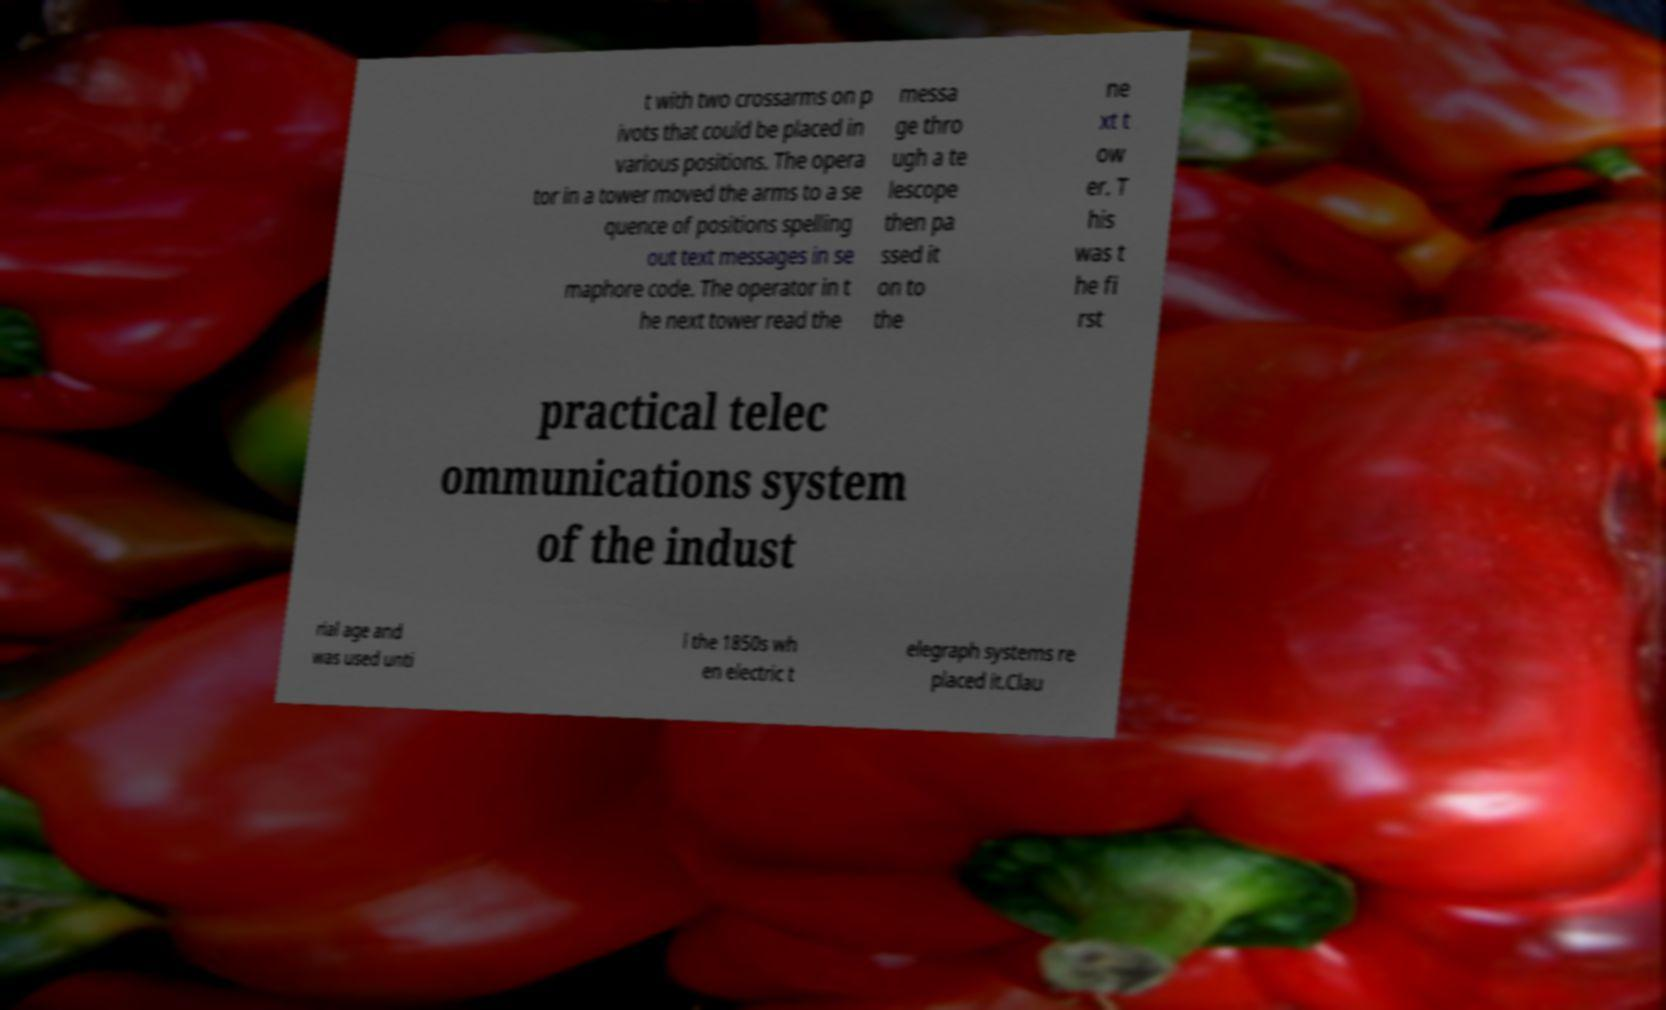What messages or text are displayed in this image? I need them in a readable, typed format. t with two crossarms on p ivots that could be placed in various positions. The opera tor in a tower moved the arms to a se quence of positions spelling out text messages in se maphore code. The operator in t he next tower read the messa ge thro ugh a te lescope then pa ssed it on to the ne xt t ow er. T his was t he fi rst practical telec ommunications system of the indust rial age and was used unti l the 1850s wh en electric t elegraph systems re placed it.Clau 